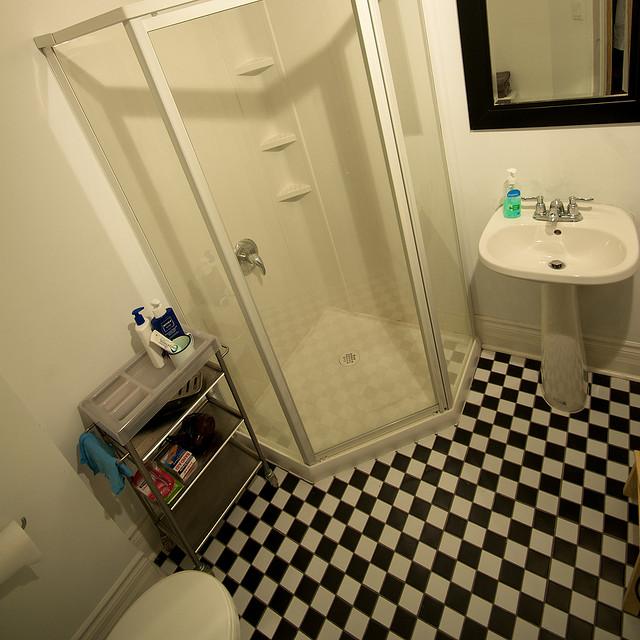Is the shower door closed?
Answer briefly. Yes. What pattern is the floor tile?
Answer briefly. Checkered. What type of sink is that?
Keep it brief. Pedestal. What shape is the sink?
Keep it brief. Oval. What are the panel's made of?
Give a very brief answer. Glass. Is this in a restaurant?
Answer briefly. No. Is this a modern shower?
Keep it brief. Yes. 